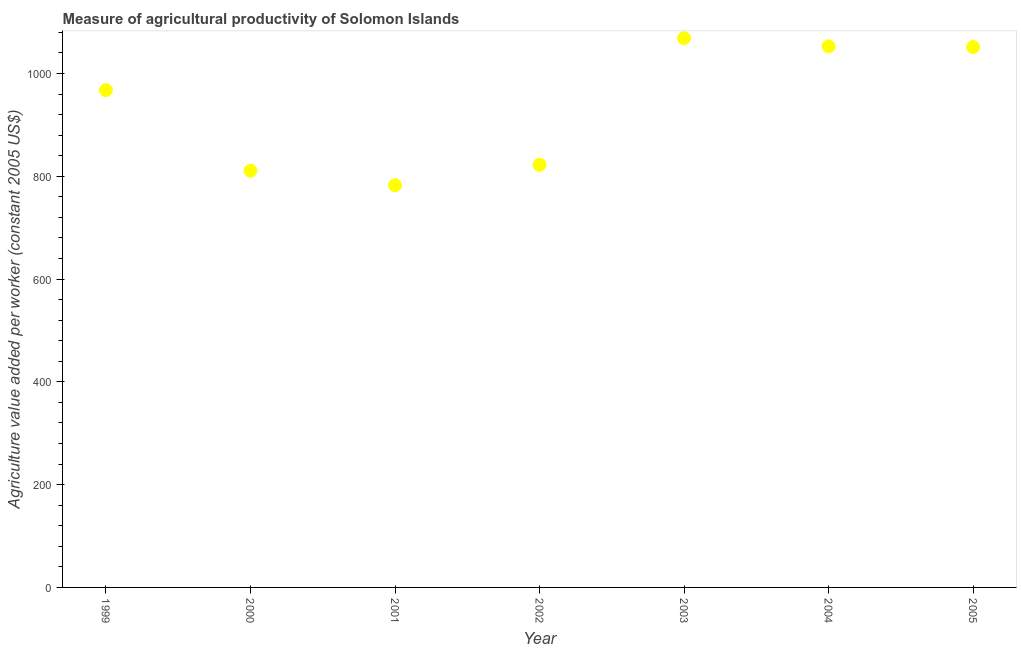What is the agriculture value added per worker in 2000?
Ensure brevity in your answer.  810.78. Across all years, what is the maximum agriculture value added per worker?
Give a very brief answer. 1068.71. Across all years, what is the minimum agriculture value added per worker?
Ensure brevity in your answer.  782.48. In which year was the agriculture value added per worker minimum?
Provide a short and direct response. 2001. What is the sum of the agriculture value added per worker?
Make the answer very short. 6556.5. What is the difference between the agriculture value added per worker in 1999 and 2001?
Your response must be concise. 185.18. What is the average agriculture value added per worker per year?
Keep it short and to the point. 936.64. What is the median agriculture value added per worker?
Provide a short and direct response. 967.66. In how many years, is the agriculture value added per worker greater than 600 US$?
Ensure brevity in your answer.  7. What is the ratio of the agriculture value added per worker in 2003 to that in 2005?
Give a very brief answer. 1.02. Is the agriculture value added per worker in 1999 less than that in 2003?
Make the answer very short. Yes. Is the difference between the agriculture value added per worker in 2004 and 2005 greater than the difference between any two years?
Offer a terse response. No. What is the difference between the highest and the second highest agriculture value added per worker?
Keep it short and to the point. 15.8. What is the difference between the highest and the lowest agriculture value added per worker?
Ensure brevity in your answer.  286.23. Does the agriculture value added per worker monotonically increase over the years?
Your answer should be compact. No. How many dotlines are there?
Your answer should be very brief. 1. How many years are there in the graph?
Give a very brief answer. 7. What is the difference between two consecutive major ticks on the Y-axis?
Provide a succinct answer. 200. Are the values on the major ticks of Y-axis written in scientific E-notation?
Offer a terse response. No. Does the graph contain any zero values?
Offer a very short reply. No. Does the graph contain grids?
Keep it short and to the point. No. What is the title of the graph?
Make the answer very short. Measure of agricultural productivity of Solomon Islands. What is the label or title of the Y-axis?
Provide a short and direct response. Agriculture value added per worker (constant 2005 US$). What is the Agriculture value added per worker (constant 2005 US$) in 1999?
Offer a terse response. 967.66. What is the Agriculture value added per worker (constant 2005 US$) in 2000?
Your response must be concise. 810.78. What is the Agriculture value added per worker (constant 2005 US$) in 2001?
Provide a short and direct response. 782.48. What is the Agriculture value added per worker (constant 2005 US$) in 2002?
Offer a very short reply. 822.41. What is the Agriculture value added per worker (constant 2005 US$) in 2003?
Ensure brevity in your answer.  1068.71. What is the Agriculture value added per worker (constant 2005 US$) in 2004?
Give a very brief answer. 1052.91. What is the Agriculture value added per worker (constant 2005 US$) in 2005?
Make the answer very short. 1051.55. What is the difference between the Agriculture value added per worker (constant 2005 US$) in 1999 and 2000?
Keep it short and to the point. 156.88. What is the difference between the Agriculture value added per worker (constant 2005 US$) in 1999 and 2001?
Give a very brief answer. 185.18. What is the difference between the Agriculture value added per worker (constant 2005 US$) in 1999 and 2002?
Your answer should be very brief. 145.25. What is the difference between the Agriculture value added per worker (constant 2005 US$) in 1999 and 2003?
Offer a terse response. -101.06. What is the difference between the Agriculture value added per worker (constant 2005 US$) in 1999 and 2004?
Keep it short and to the point. -85.25. What is the difference between the Agriculture value added per worker (constant 2005 US$) in 1999 and 2005?
Provide a short and direct response. -83.89. What is the difference between the Agriculture value added per worker (constant 2005 US$) in 2000 and 2001?
Your answer should be very brief. 28.3. What is the difference between the Agriculture value added per worker (constant 2005 US$) in 2000 and 2002?
Make the answer very short. -11.63. What is the difference between the Agriculture value added per worker (constant 2005 US$) in 2000 and 2003?
Offer a very short reply. -257.93. What is the difference between the Agriculture value added per worker (constant 2005 US$) in 2000 and 2004?
Ensure brevity in your answer.  -242.13. What is the difference between the Agriculture value added per worker (constant 2005 US$) in 2000 and 2005?
Your answer should be compact. -240.77. What is the difference between the Agriculture value added per worker (constant 2005 US$) in 2001 and 2002?
Make the answer very short. -39.93. What is the difference between the Agriculture value added per worker (constant 2005 US$) in 2001 and 2003?
Offer a very short reply. -286.23. What is the difference between the Agriculture value added per worker (constant 2005 US$) in 2001 and 2004?
Ensure brevity in your answer.  -270.43. What is the difference between the Agriculture value added per worker (constant 2005 US$) in 2001 and 2005?
Ensure brevity in your answer.  -269.07. What is the difference between the Agriculture value added per worker (constant 2005 US$) in 2002 and 2003?
Your answer should be compact. -246.3. What is the difference between the Agriculture value added per worker (constant 2005 US$) in 2002 and 2004?
Provide a succinct answer. -230.5. What is the difference between the Agriculture value added per worker (constant 2005 US$) in 2002 and 2005?
Make the answer very short. -229.14. What is the difference between the Agriculture value added per worker (constant 2005 US$) in 2003 and 2004?
Provide a short and direct response. 15.8. What is the difference between the Agriculture value added per worker (constant 2005 US$) in 2003 and 2005?
Make the answer very short. 17.16. What is the difference between the Agriculture value added per worker (constant 2005 US$) in 2004 and 2005?
Give a very brief answer. 1.36. What is the ratio of the Agriculture value added per worker (constant 2005 US$) in 1999 to that in 2000?
Give a very brief answer. 1.19. What is the ratio of the Agriculture value added per worker (constant 2005 US$) in 1999 to that in 2001?
Offer a terse response. 1.24. What is the ratio of the Agriculture value added per worker (constant 2005 US$) in 1999 to that in 2002?
Make the answer very short. 1.18. What is the ratio of the Agriculture value added per worker (constant 2005 US$) in 1999 to that in 2003?
Your answer should be very brief. 0.91. What is the ratio of the Agriculture value added per worker (constant 2005 US$) in 1999 to that in 2004?
Your answer should be compact. 0.92. What is the ratio of the Agriculture value added per worker (constant 2005 US$) in 2000 to that in 2001?
Ensure brevity in your answer.  1.04. What is the ratio of the Agriculture value added per worker (constant 2005 US$) in 2000 to that in 2003?
Provide a succinct answer. 0.76. What is the ratio of the Agriculture value added per worker (constant 2005 US$) in 2000 to that in 2004?
Provide a succinct answer. 0.77. What is the ratio of the Agriculture value added per worker (constant 2005 US$) in 2000 to that in 2005?
Make the answer very short. 0.77. What is the ratio of the Agriculture value added per worker (constant 2005 US$) in 2001 to that in 2002?
Provide a succinct answer. 0.95. What is the ratio of the Agriculture value added per worker (constant 2005 US$) in 2001 to that in 2003?
Your answer should be very brief. 0.73. What is the ratio of the Agriculture value added per worker (constant 2005 US$) in 2001 to that in 2004?
Your answer should be compact. 0.74. What is the ratio of the Agriculture value added per worker (constant 2005 US$) in 2001 to that in 2005?
Your response must be concise. 0.74. What is the ratio of the Agriculture value added per worker (constant 2005 US$) in 2002 to that in 2003?
Keep it short and to the point. 0.77. What is the ratio of the Agriculture value added per worker (constant 2005 US$) in 2002 to that in 2004?
Provide a short and direct response. 0.78. What is the ratio of the Agriculture value added per worker (constant 2005 US$) in 2002 to that in 2005?
Keep it short and to the point. 0.78. What is the ratio of the Agriculture value added per worker (constant 2005 US$) in 2003 to that in 2005?
Offer a very short reply. 1.02. What is the ratio of the Agriculture value added per worker (constant 2005 US$) in 2004 to that in 2005?
Provide a short and direct response. 1. 